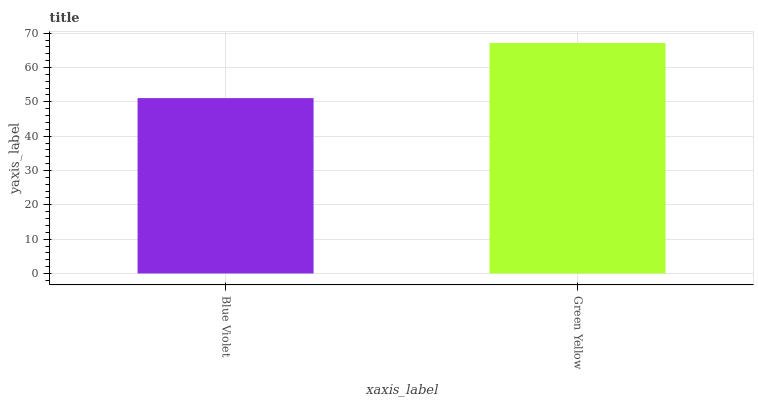Is Blue Violet the minimum?
Answer yes or no. Yes. Is Green Yellow the maximum?
Answer yes or no. Yes. Is Green Yellow the minimum?
Answer yes or no. No. Is Green Yellow greater than Blue Violet?
Answer yes or no. Yes. Is Blue Violet less than Green Yellow?
Answer yes or no. Yes. Is Blue Violet greater than Green Yellow?
Answer yes or no. No. Is Green Yellow less than Blue Violet?
Answer yes or no. No. Is Green Yellow the high median?
Answer yes or no. Yes. Is Blue Violet the low median?
Answer yes or no. Yes. Is Blue Violet the high median?
Answer yes or no. No. Is Green Yellow the low median?
Answer yes or no. No. 